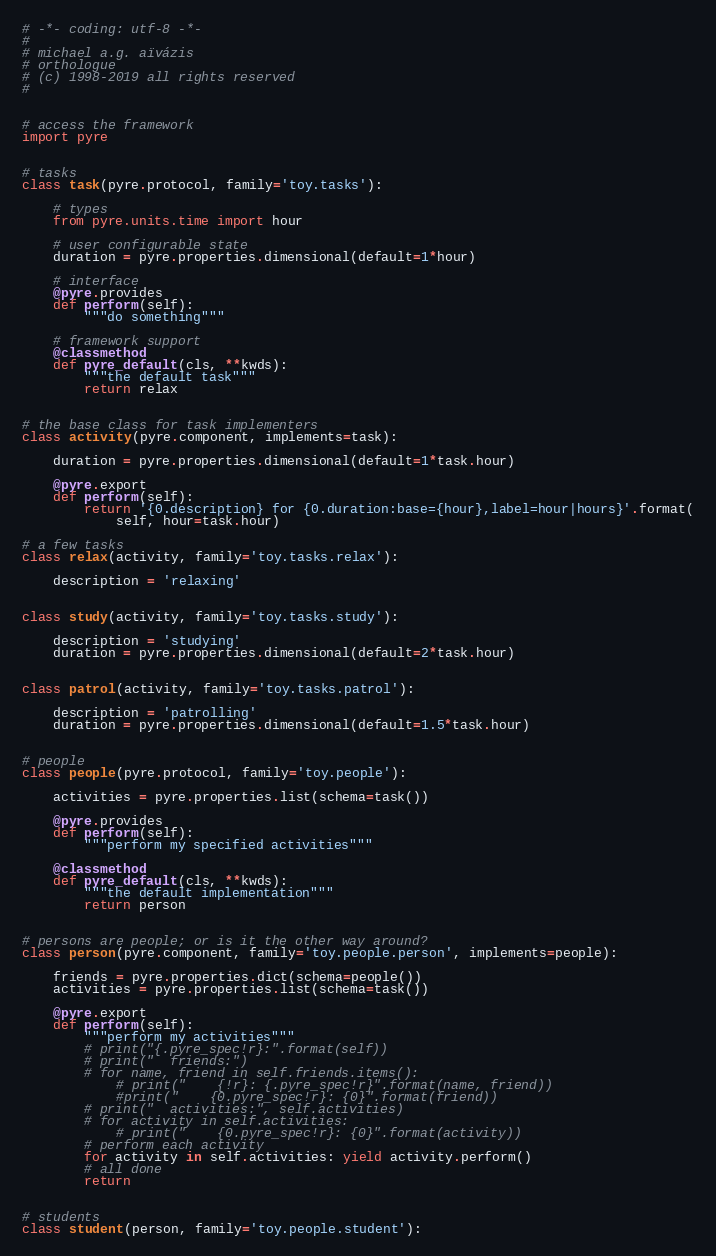Convert code to text. <code><loc_0><loc_0><loc_500><loc_500><_Python_># -*- coding: utf-8 -*-
#
# michael a.g. aïvázis
# orthologue
# (c) 1998-2019 all rights reserved
#


# access the framework
import pyre


# tasks
class task(pyre.protocol, family='toy.tasks'):

    # types
    from pyre.units.time import hour

    # user configurable state
    duration = pyre.properties.dimensional(default=1*hour)

    # interface
    @pyre.provides
    def perform(self):
        """do something"""

    # framework support
    @classmethod
    def pyre_default(cls, **kwds):
        """the default task"""
        return relax


# the base class for task implementers
class activity(pyre.component, implements=task):

    duration = pyre.properties.dimensional(default=1*task.hour)

    @pyre.export
    def perform(self):
        return '{0.description} for {0.duration:base={hour},label=hour|hours}'.format(
            self, hour=task.hour)

# a few tasks
class relax(activity, family='toy.tasks.relax'):

    description = 'relaxing'


class study(activity, family='toy.tasks.study'):

    description = 'studying'
    duration = pyre.properties.dimensional(default=2*task.hour)


class patrol(activity, family='toy.tasks.patrol'):

    description = 'patrolling'
    duration = pyre.properties.dimensional(default=1.5*task.hour)


# people
class people(pyre.protocol, family='toy.people'):

    activities = pyre.properties.list(schema=task())

    @pyre.provides
    def perform(self):
        """perform my specified activities"""

    @classmethod
    def pyre_default(cls, **kwds):
        """the default implementation"""
        return person


# persons are people; or is it the other way around?
class person(pyre.component, family='toy.people.person', implements=people):

    friends = pyre.properties.dict(schema=people())
    activities = pyre.properties.list(schema=task())

    @pyre.export
    def perform(self):
        """perform my activities"""
        # print("{.pyre_spec!r}:".format(self))
        # print("  friends:")
        # for name, friend in self.friends.items():
            # print("    {!r}: {.pyre_spec!r}".format(name, friend))
            #print("    {0.pyre_spec!r}: {0}".format(friend))
        # print("  activities:", self.activities)
        # for activity in self.activities:
            # print("    {0.pyre_spec!r}: {0}".format(activity))
        # perform each activity
        for activity in self.activities: yield activity.perform()
        # all done
        return


# students
class student(person, family='toy.people.student'):
</code> 